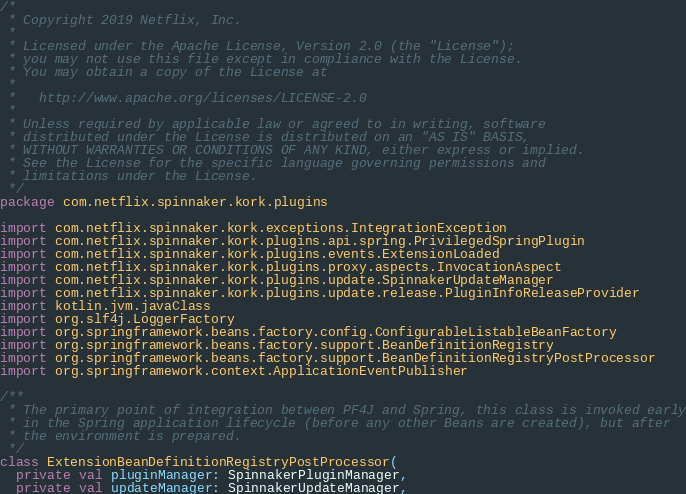Convert code to text. <code><loc_0><loc_0><loc_500><loc_500><_Kotlin_>/*
 * Copyright 2019 Netflix, Inc.
 *
 * Licensed under the Apache License, Version 2.0 (the "License");
 * you may not use this file except in compliance with the License.
 * You may obtain a copy of the License at
 *
 *   http://www.apache.org/licenses/LICENSE-2.0
 *
 * Unless required by applicable law or agreed to in writing, software
 * distributed under the License is distributed on an "AS IS" BASIS,
 * WITHOUT WARRANTIES OR CONDITIONS OF ANY KIND, either express or implied.
 * See the License for the specific language governing permissions and
 * limitations under the License.
 */
package com.netflix.spinnaker.kork.plugins

import com.netflix.spinnaker.kork.exceptions.IntegrationException
import com.netflix.spinnaker.kork.plugins.api.spring.PrivilegedSpringPlugin
import com.netflix.spinnaker.kork.plugins.events.ExtensionLoaded
import com.netflix.spinnaker.kork.plugins.proxy.aspects.InvocationAspect
import com.netflix.spinnaker.kork.plugins.update.SpinnakerUpdateManager
import com.netflix.spinnaker.kork.plugins.update.release.PluginInfoReleaseProvider
import kotlin.jvm.javaClass
import org.slf4j.LoggerFactory
import org.springframework.beans.factory.config.ConfigurableListableBeanFactory
import org.springframework.beans.factory.support.BeanDefinitionRegistry
import org.springframework.beans.factory.support.BeanDefinitionRegistryPostProcessor
import org.springframework.context.ApplicationEventPublisher

/**
 * The primary point of integration between PF4J and Spring, this class is invoked early
 * in the Spring application lifecycle (before any other Beans are created), but after
 * the environment is prepared.
 */
class ExtensionBeanDefinitionRegistryPostProcessor(
  private val pluginManager: SpinnakerPluginManager,
  private val updateManager: SpinnakerUpdateManager,</code> 